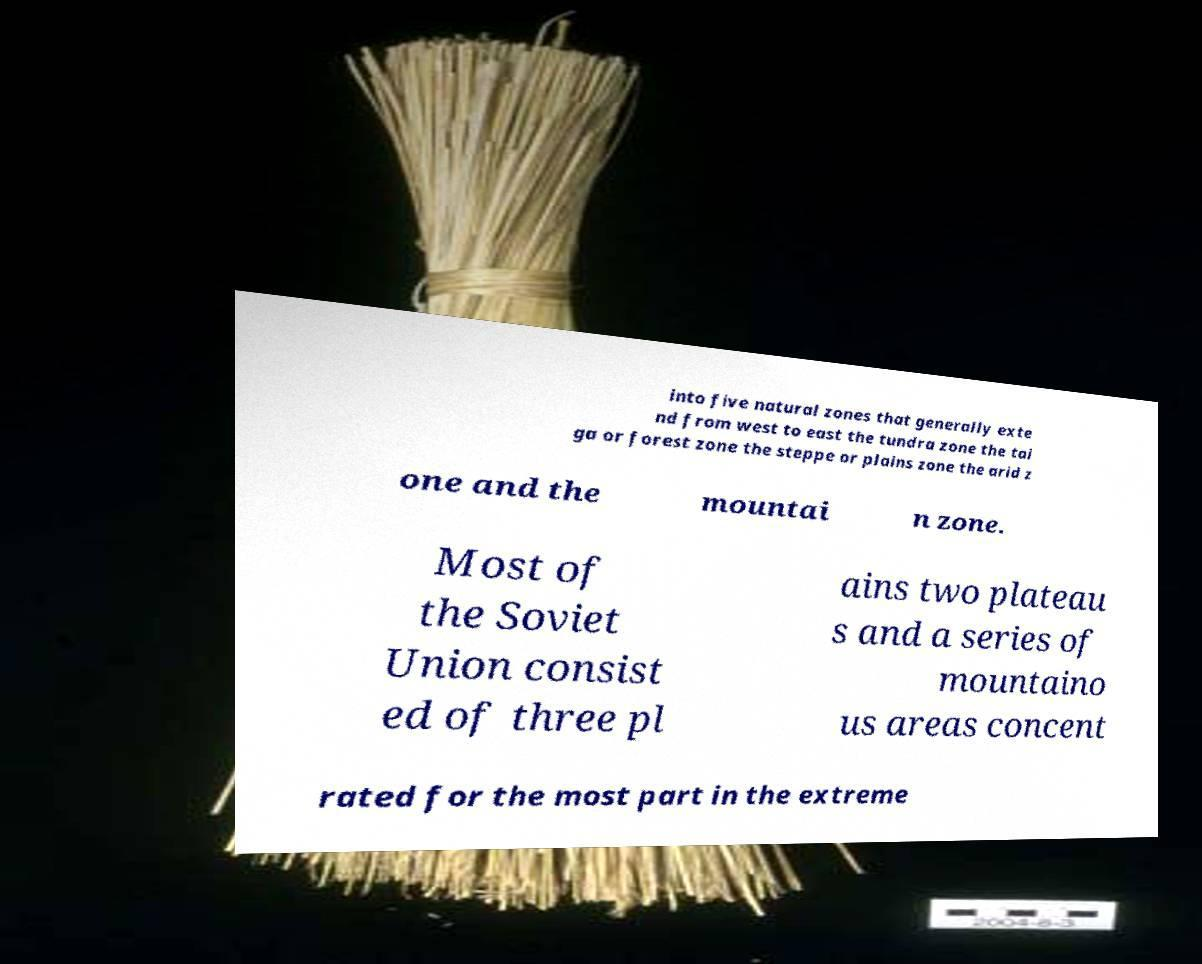I need the written content from this picture converted into text. Can you do that? into five natural zones that generally exte nd from west to east the tundra zone the tai ga or forest zone the steppe or plains zone the arid z one and the mountai n zone. Most of the Soviet Union consist ed of three pl ains two plateau s and a series of mountaino us areas concent rated for the most part in the extreme 